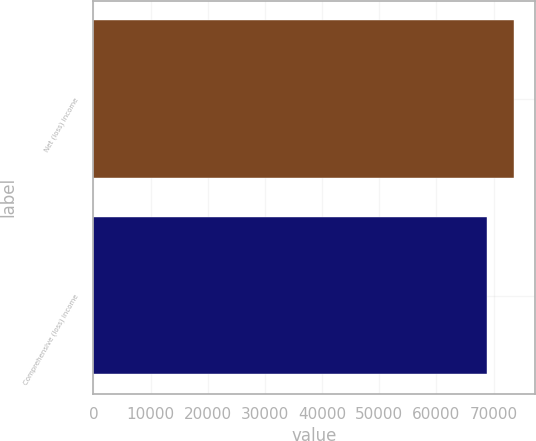Convert chart. <chart><loc_0><loc_0><loc_500><loc_500><bar_chart><fcel>Net (loss) income<fcel>Comprehensive (loss) income<nl><fcel>73634<fcel>68839<nl></chart> 